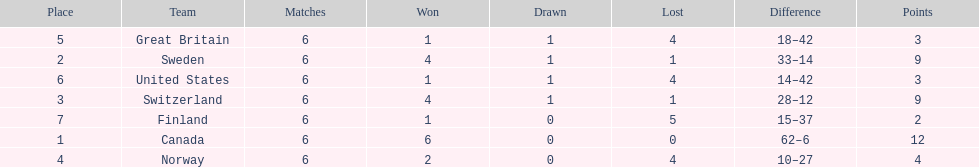What team placed after canada? Sweden. 